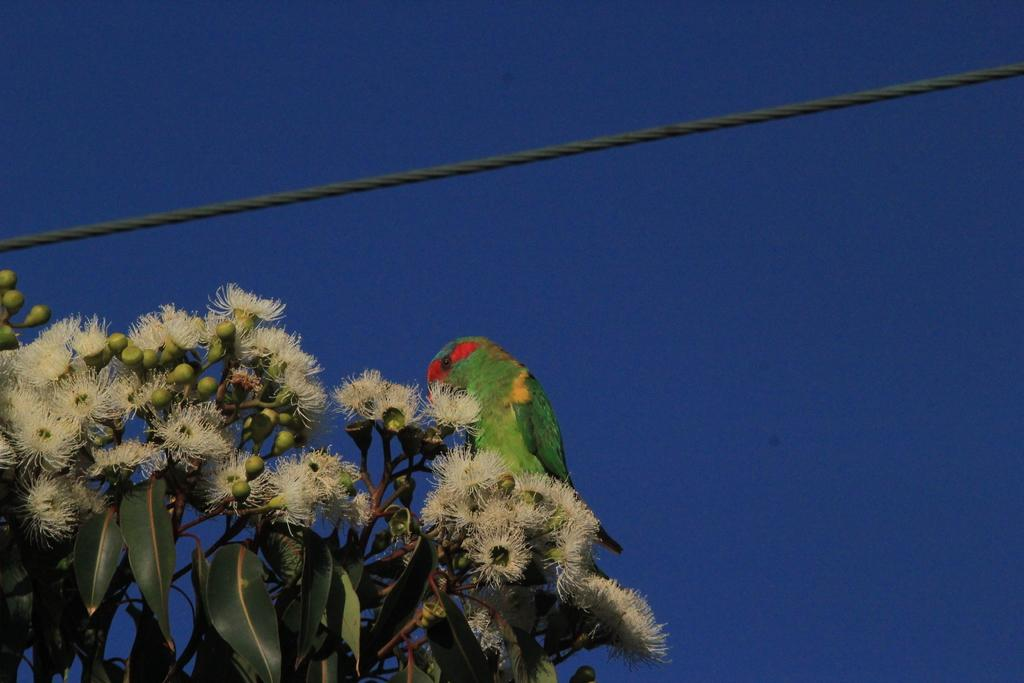What type of animal can be seen in the image? There is a bird in the image. What type of plant elements are present in the image? There are leaves, buds, flowers, and stems in the image. What is the purpose of the wire in the image? The wire's purpose is not specified, but it could be used for supporting or attaching the plant elements. What can be seen in the background of the image? The sky is visible in the background of the image. What is the color of the sky in the image? The color of the sky is blue. How many books are stacked on the bird in the image? There are no books present in the image; it features a bird, plant elements, and a wire. What type of wound is visible on the bird in the image? There is no wound visible on the bird in the image. 